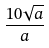<formula> <loc_0><loc_0><loc_500><loc_500>\frac { 1 0 \sqrt { a } } { a }</formula> 